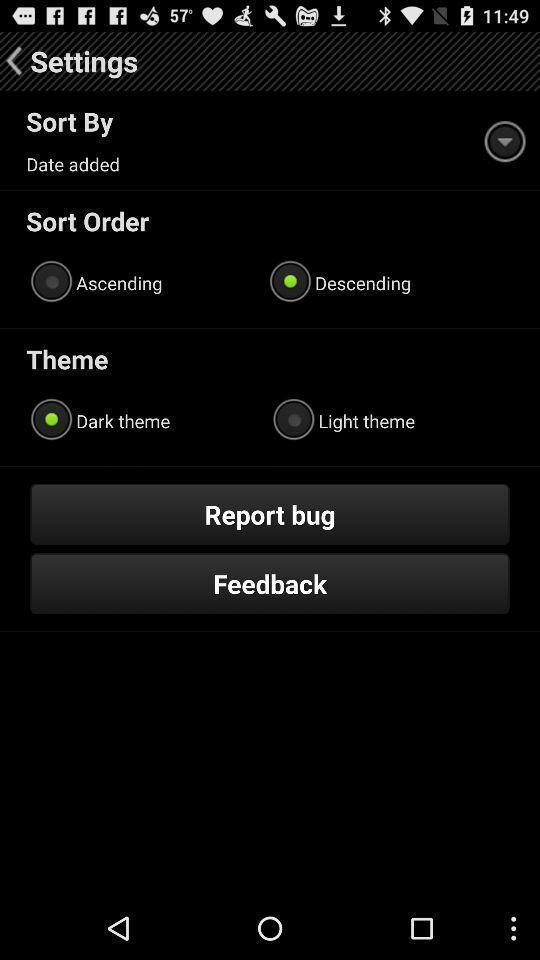Give me a summary of this screen capture. Screen displaying settings. 